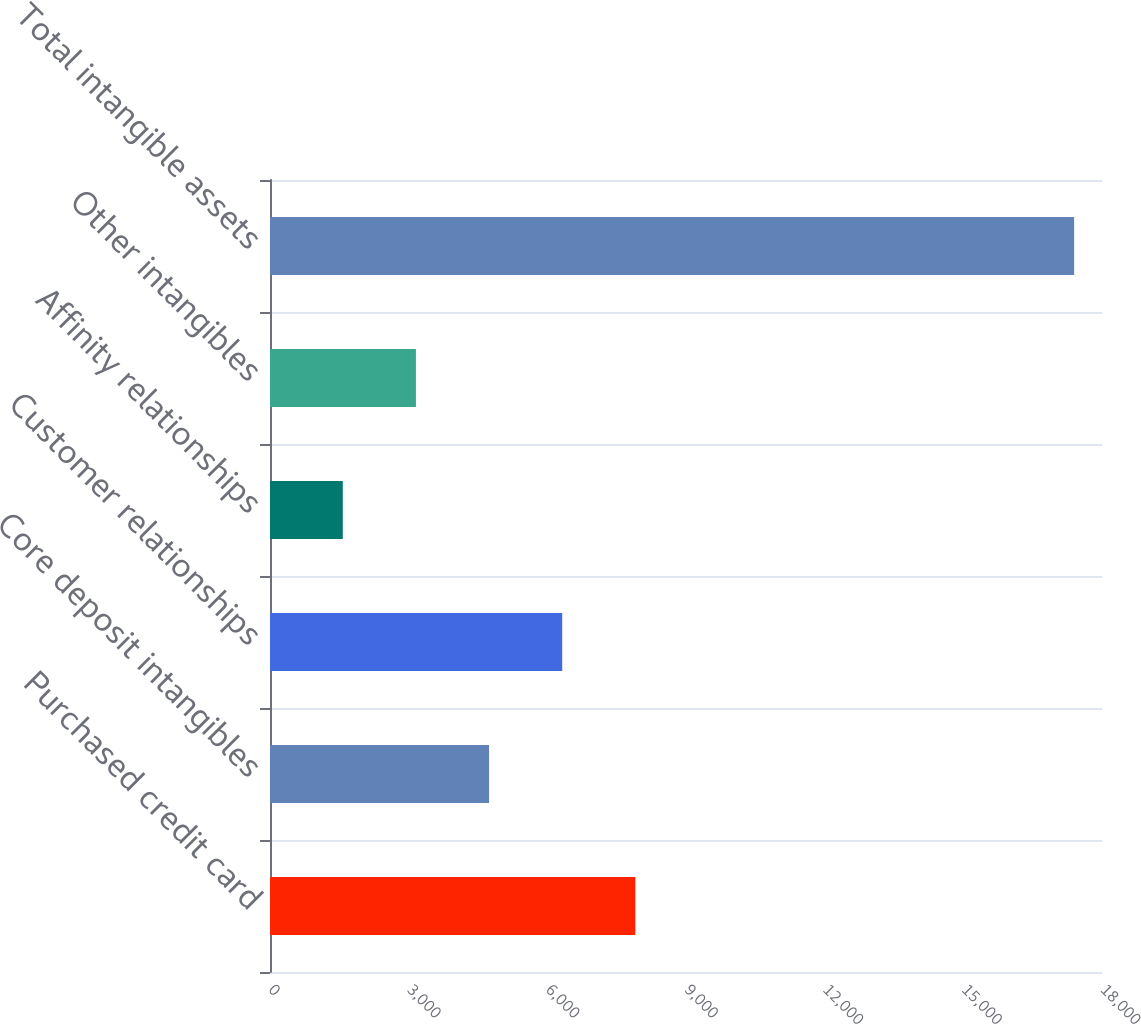Convert chart to OTSL. <chart><loc_0><loc_0><loc_500><loc_500><bar_chart><fcel>Purchased credit card<fcel>Core deposit intangibles<fcel>Customer relationships<fcel>Affinity relationships<fcel>Other intangibles<fcel>Total intangible assets<nl><fcel>7903.8<fcel>4739.4<fcel>6321.6<fcel>1575<fcel>3157.2<fcel>17397<nl></chart> 